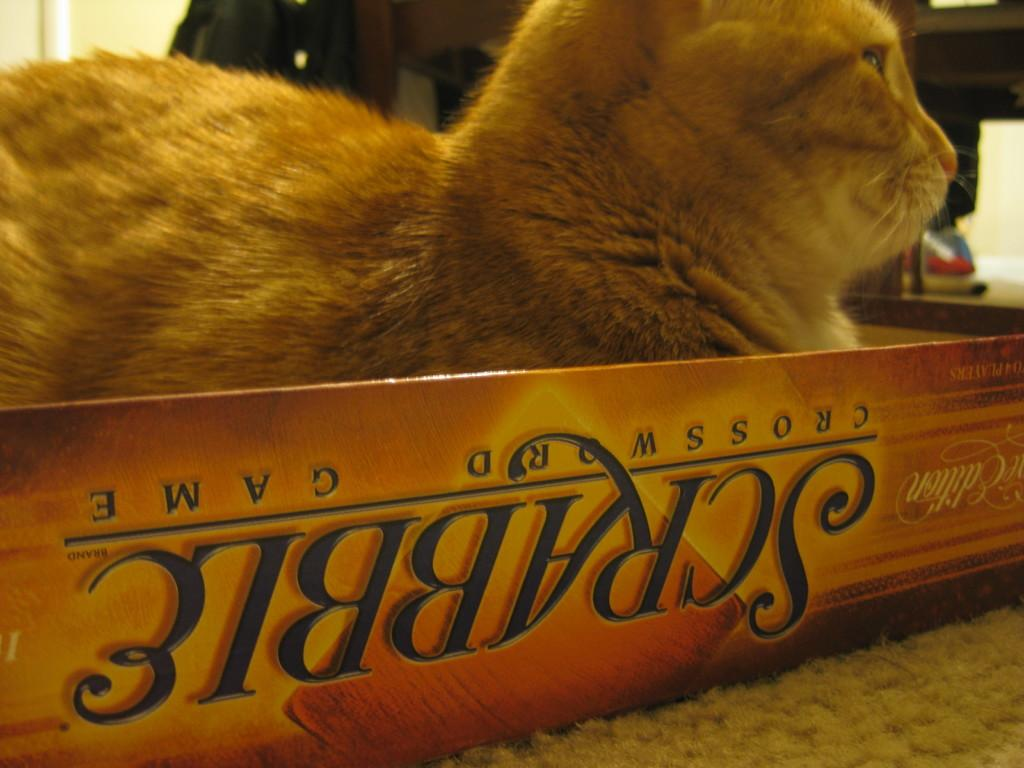Who or what is the main subject in the image? There is a person in the image. What is the person holding in the image? The person is holding a brown-colored cat. Where is the cat located in the image? The cat is in a box. What is the color of the background in the image? The background of the image is white. Can you describe any objects in the background? There are some objects in the background. How does the person in the image comfort the tax? There is no mention of a tax in the image, so it cannot be comforted. 